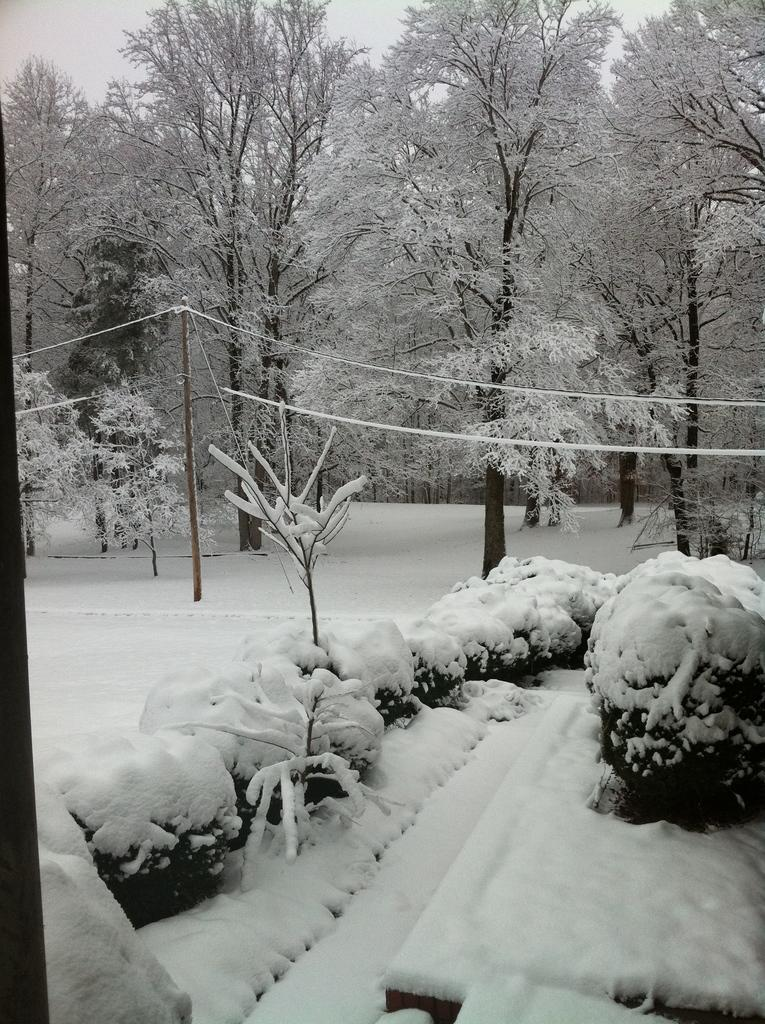What is the color scheme of the image? The image is black and white. What object can be seen standing upright in the image? There is a pole in the image. What is the condition of the plants in the image? The plants are covered with snow in the image. What type of vegetation is present in the image? Trees are present in the image. What is visible in the background of the image? The sky is visible in the image. What type of feather can be seen falling from the sky in the image? There is no feather visible in the image; it is a black and white image with a pole, plants, trees, and sky. Can you tell me how many pairs of shoes are present in the image? There are no shoes present in the image. 